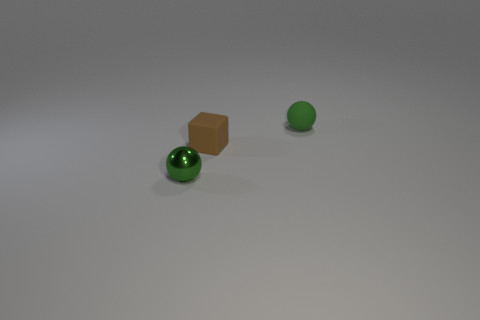Is the number of matte blocks greater than the number of big purple metal blocks?
Your response must be concise. Yes. What number of objects are either tiny blue metal cylinders or objects that are on the left side of the green rubber object?
Provide a succinct answer. 2. Is the size of the shiny object the same as the green matte thing?
Give a very brief answer. Yes. There is a small rubber cube; are there any tiny green rubber things in front of it?
Give a very brief answer. No. What size is the object that is both in front of the rubber ball and behind the tiny green metallic ball?
Your answer should be very brief. Small. What number of objects are either tiny blocks or green balls?
Make the answer very short. 3. There is a matte sphere; does it have the same size as the metallic object that is on the left side of the brown cube?
Your answer should be very brief. Yes. What is the size of the green sphere right of the ball that is on the left side of the small ball right of the green metallic sphere?
Offer a terse response. Small. Is there a ball?
Keep it short and to the point. Yes. There is another object that is the same color as the small shiny thing; what is it made of?
Provide a succinct answer. Rubber. 